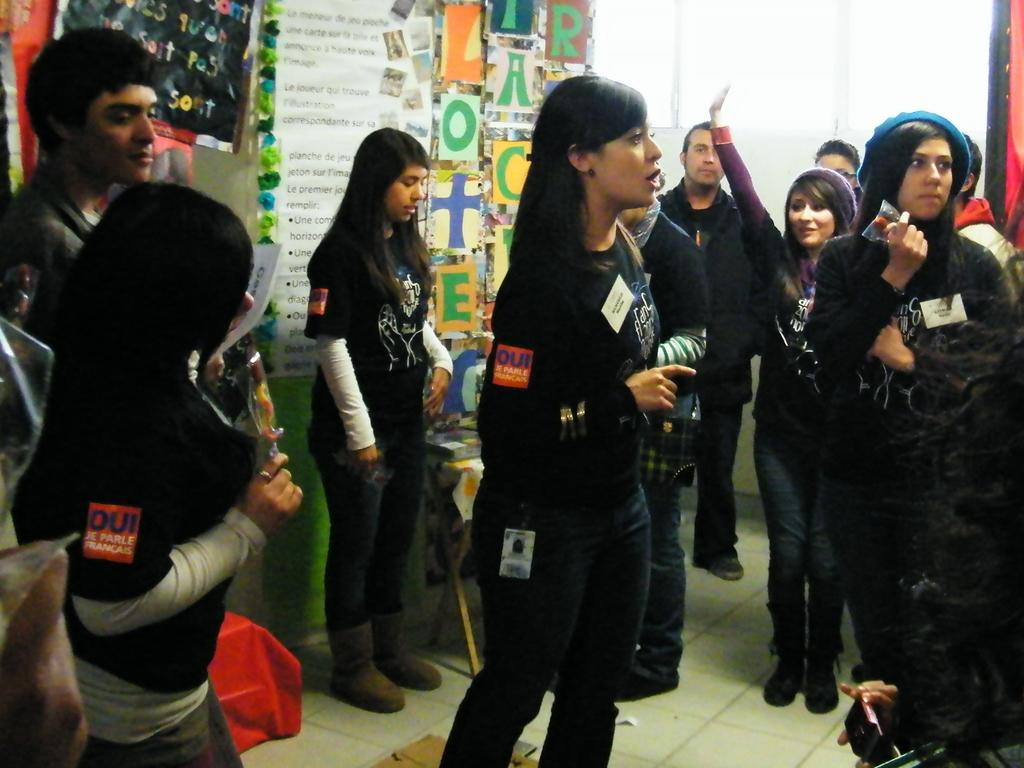What can be seen in the image? There are people standing in the image. Where are the people standing? The people are standing on the floor. What is visible in the background of the image? There is a wall and posters with text in the background of the image. What type of substance is being used by the people in the image? There is no substance being used by the people in the image; they are simply standing on the floor. 